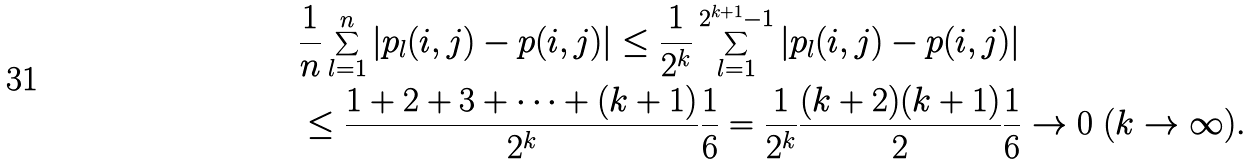<formula> <loc_0><loc_0><loc_500><loc_500>& \frac { 1 } { n } \sum _ { l = 1 } ^ { n } | p _ { l } ( i , j ) - p ( i , j ) | \leq \frac { 1 } { 2 ^ { k } } \sum _ { l = 1 } ^ { 2 ^ { k + 1 } - 1 } | p _ { l } ( i , j ) - p ( i , j ) | \\ & \leq \frac { 1 + 2 + 3 + \cdots + ( k + 1 ) } { 2 ^ { k } } \frac { 1 } { 6 } = \frac { 1 } { 2 ^ { k } } \frac { ( k + 2 ) ( k + 1 ) } { 2 } \frac { 1 } { 6 } \rightarrow 0 \ ( k \rightarrow \infty ) .</formula> 